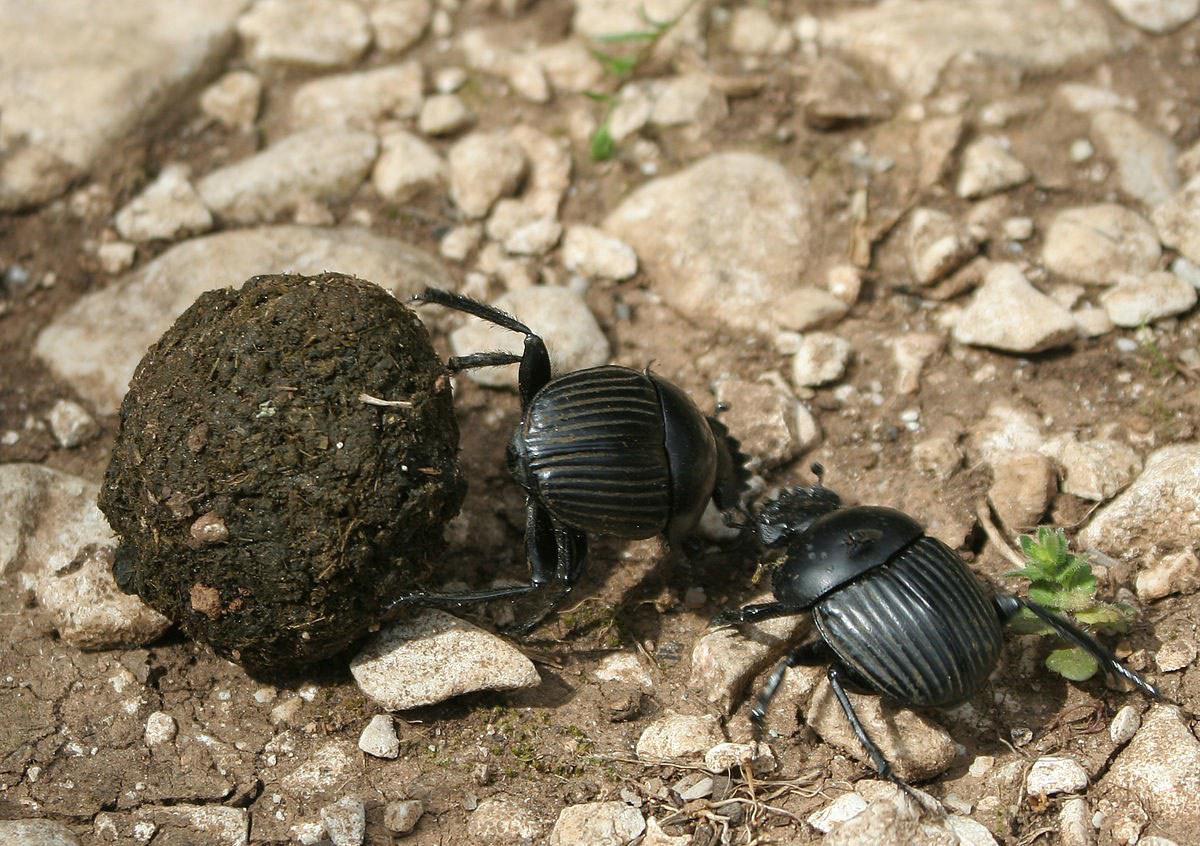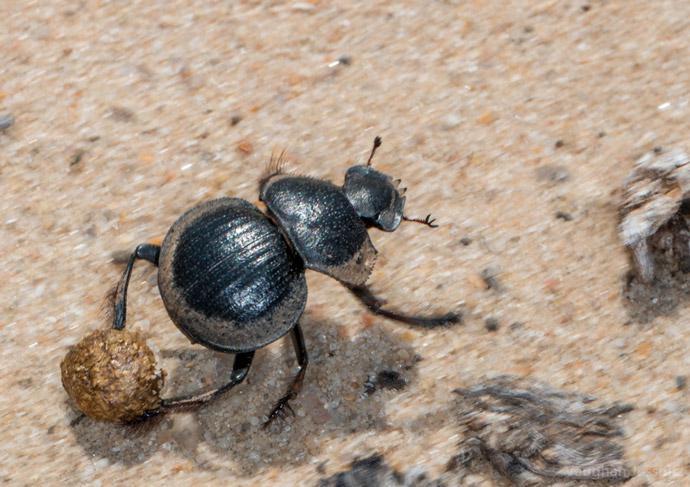The first image is the image on the left, the second image is the image on the right. For the images shown, is this caption "There is a beetle on top of a dung ball." true? Answer yes or no. No. The first image is the image on the left, the second image is the image on the right. Analyze the images presented: Is the assertion "Each image shows a beetle with a dungball that is bigger than the beetle." valid? Answer yes or no. No. 